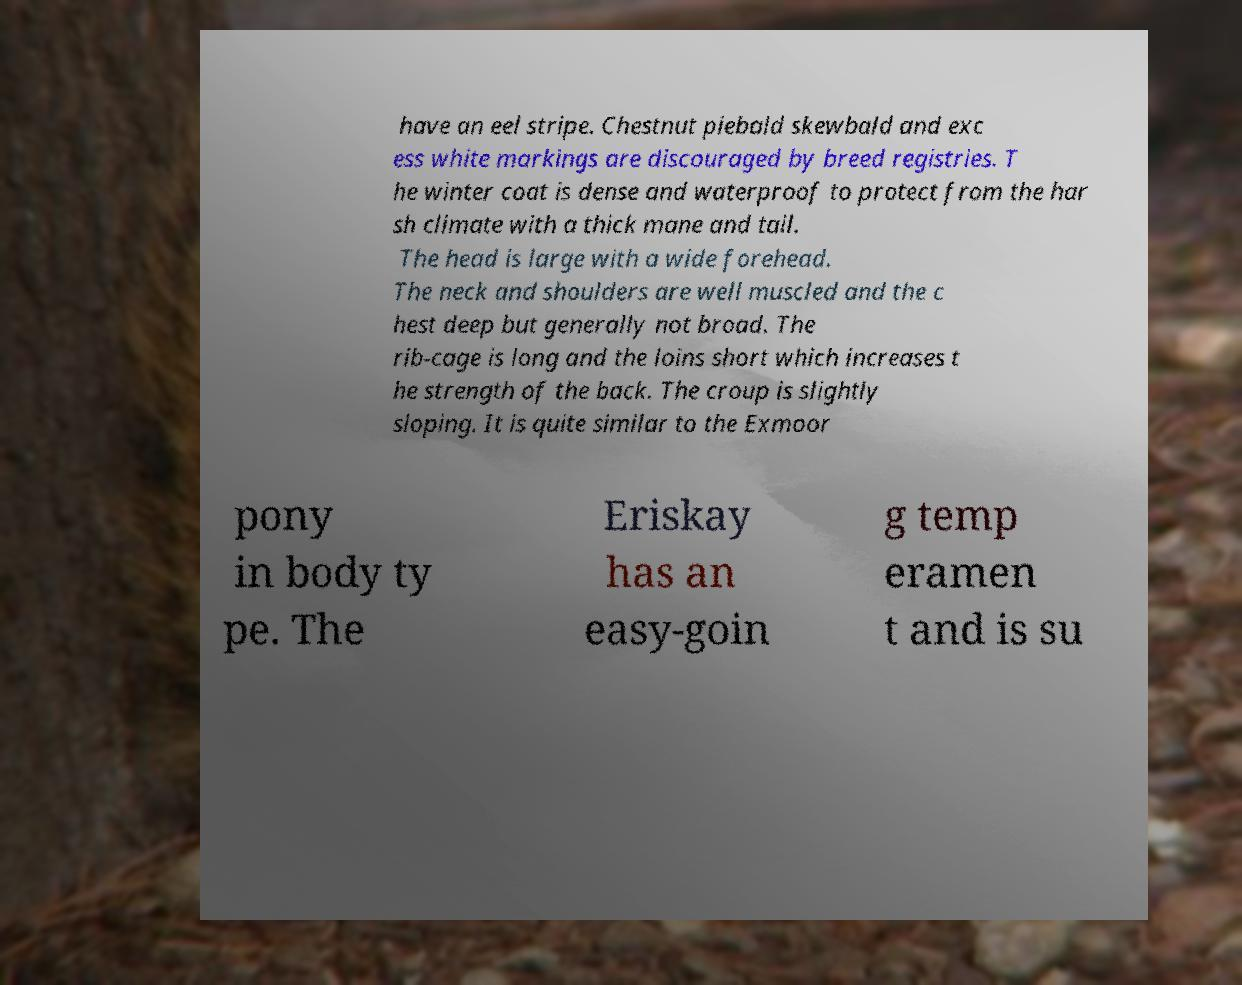Could you assist in decoding the text presented in this image and type it out clearly? have an eel stripe. Chestnut piebald skewbald and exc ess white markings are discouraged by breed registries. T he winter coat is dense and waterproof to protect from the har sh climate with a thick mane and tail. The head is large with a wide forehead. The neck and shoulders are well muscled and the c hest deep but generally not broad. The rib-cage is long and the loins short which increases t he strength of the back. The croup is slightly sloping. It is quite similar to the Exmoor pony in body ty pe. The Eriskay has an easy-goin g temp eramen t and is su 